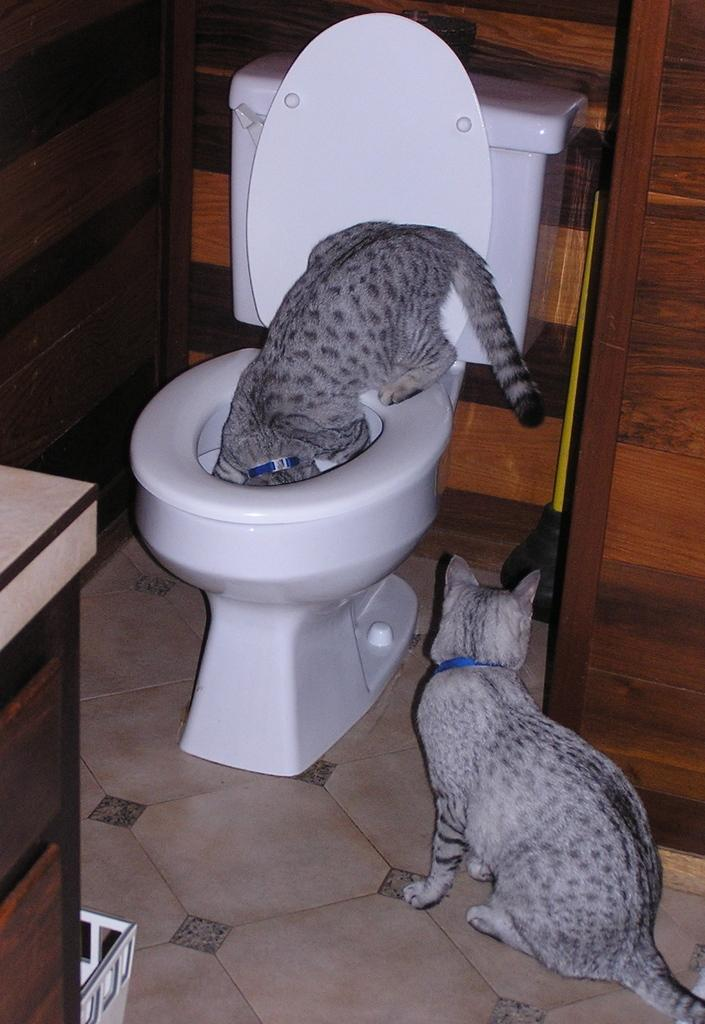What type of toilet is in the image? There is a white color western toilet in the image. What is sitting on the toilet seat? A cat is sitting on the toilet seat. Are there any other cats in the image? Yes, there is another cat sitting on the floor on the right side of the image. What can be seen behind the toilet? The wall is visible in the image. What idea does the cat sitting on the toilet have about friction? There is no indication in the image that the cat has any ideas about friction, as it is simply sitting on the toilet seat. 